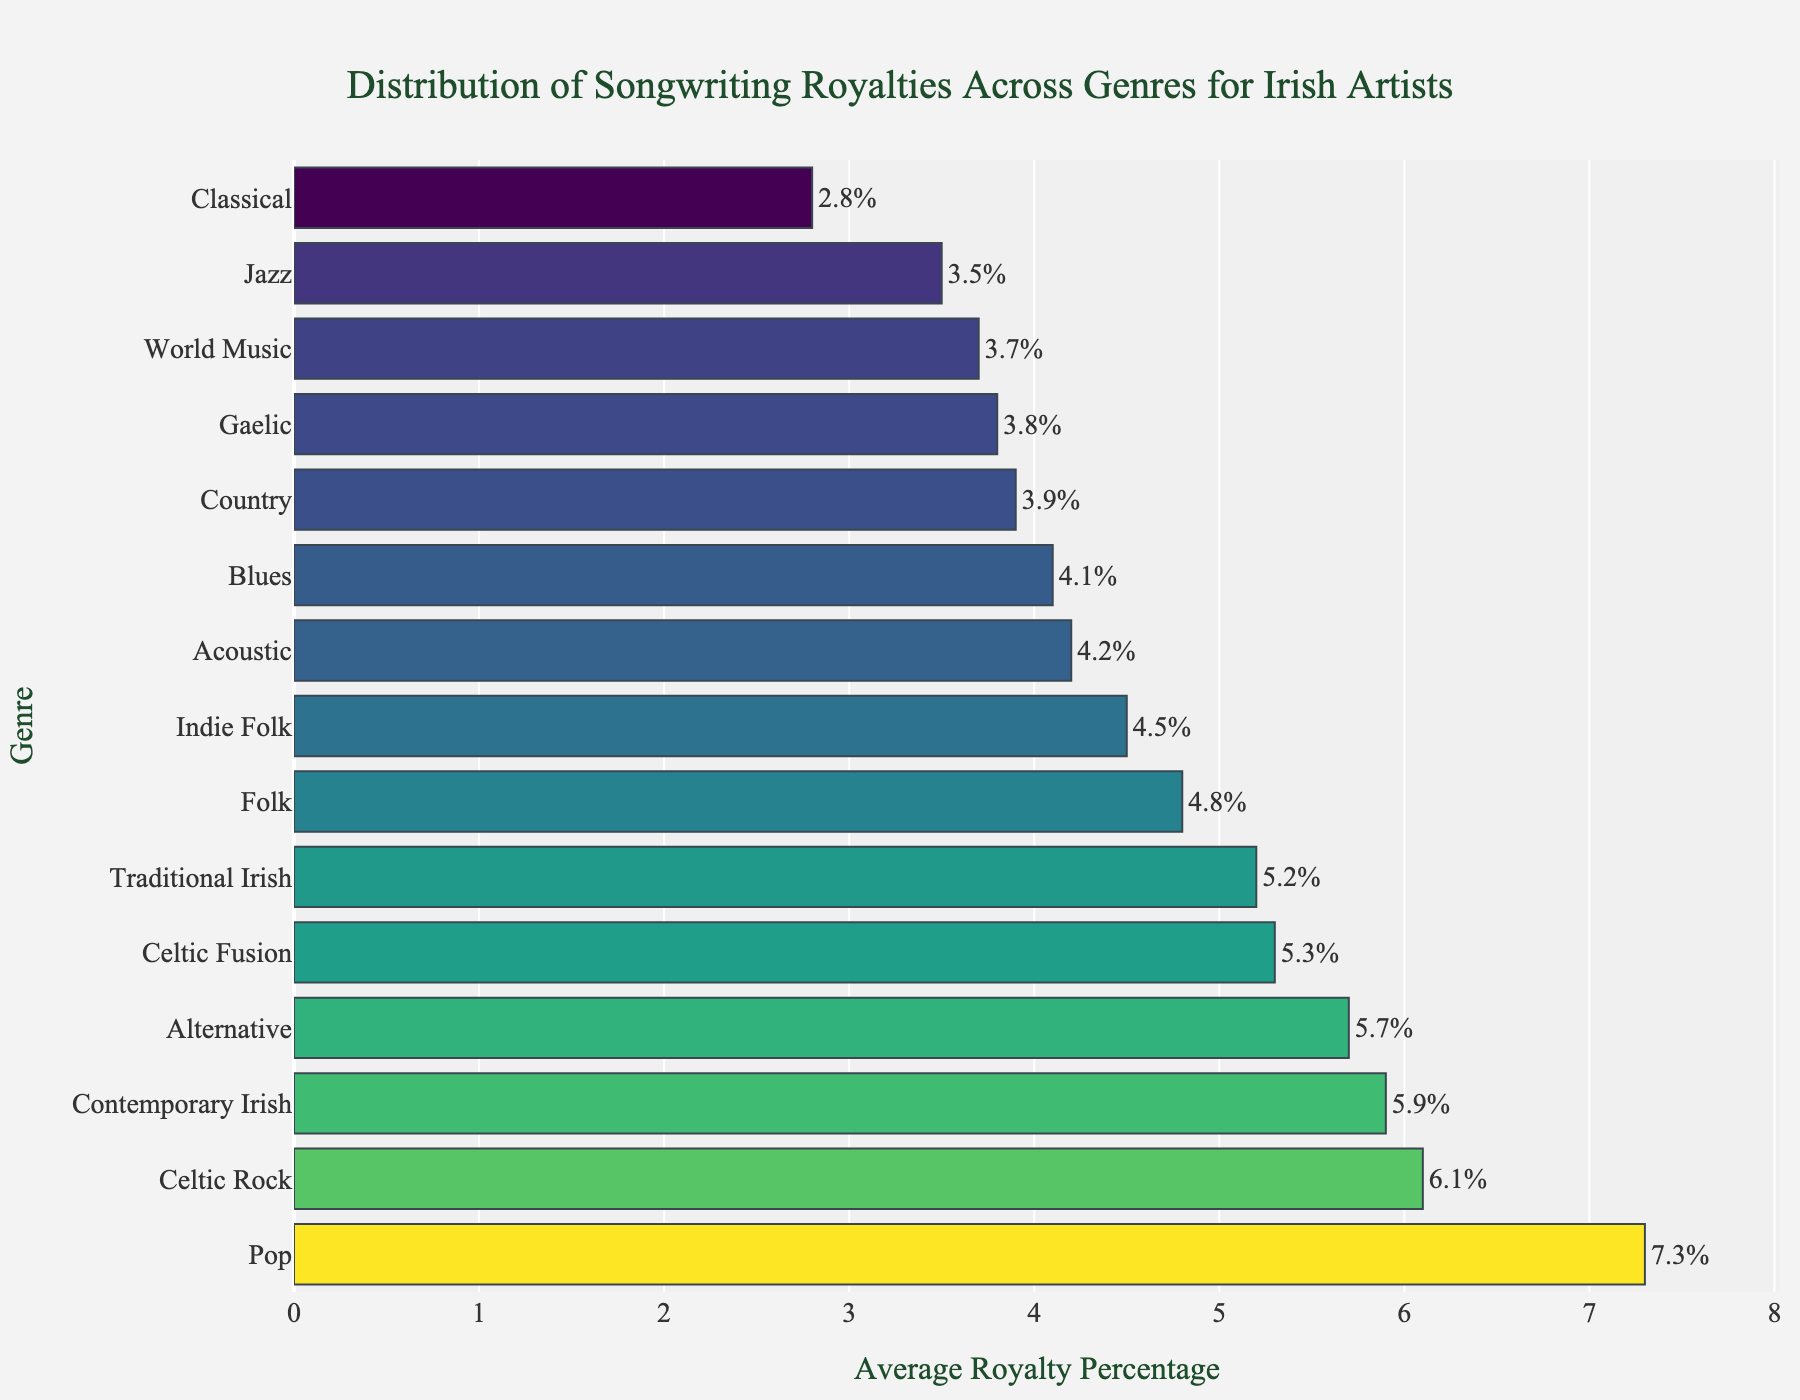Which genre has the highest average royalty percentage? Look at the bar with the longest length, which corresponds to the highest value on the x-axis. The longest bar belongs to the Pop genre.
Answer: Pop What is the average royalty percentage for the Classical genre? Locate the Classical genre on the y-axis and trace it to the corresponding value on the x-axis.
Answer: 2.8 Which genre has a higher average royalty percentage: Contemporary Irish or Traditional Irish? Compare the lengths of the bars for Contemporary Irish and Traditional Irish. The bar for Contemporary Irish is longer.
Answer: Contemporary Irish What is the combined average royalty percentage of Jazz and Blues? Find the values for Jazz and Blues and add them together: 3.5 (Jazz) + 4.1 (Blues) = 7.6.
Answer: 7.6 Is the average royalty percentage for Acoustic greater than Gaelic? Compare the lengths of the bars for Acoustic and Gaelic. The bar for Acoustic is longer.
Answer: Yes Which genres have an average royalty percentage between 4 and 5? Look for bars where the values fall between 4 and 5 on the x-axis. These genres are Folk, Blues, Indie Folk, and Acoustic.
Answer: Folk, Blues, Indie Folk, Acoustic What’s the difference in average royalty percentage between Pop and Country? Find the values for Pop and Country and subtract the smaller from the larger: 7.3 (Pop) - 3.9 (Country) = 3.4.
Answer: 3.4 Which genre shows a higher average royalty percentage: Celtic Rock or Alternative? Compare the lengths of the bars for Celtic Rock and Alternative. The bar for Celtic Rock is longer.
Answer: Celtic Rock What’s the sum of the average royalty percentages for Traditional Irish, Celtic Rock, and Alternative? Find the values for Traditional Irish, Celtic Rock, and Alternative and add them together: 5.2 + 6.1 + 5.7 = 17.
Answer: 17 